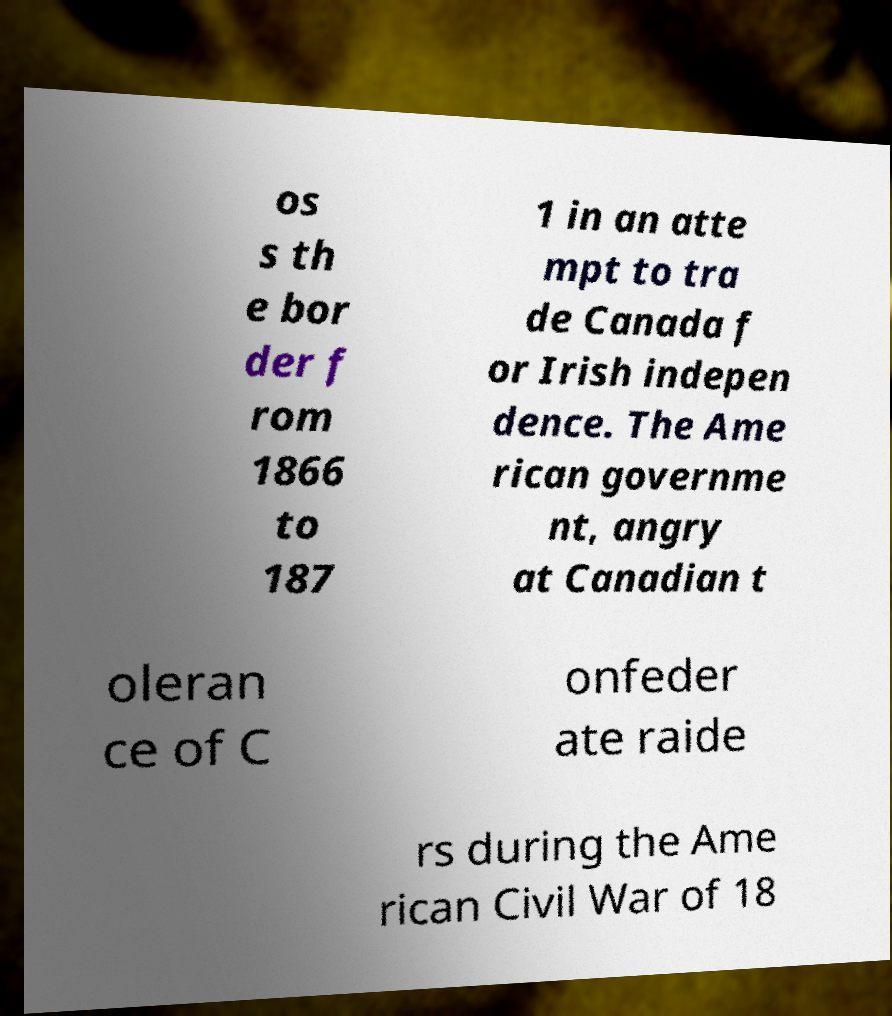I need the written content from this picture converted into text. Can you do that? os s th e bor der f rom 1866 to 187 1 in an atte mpt to tra de Canada f or Irish indepen dence. The Ame rican governme nt, angry at Canadian t oleran ce of C onfeder ate raide rs during the Ame rican Civil War of 18 